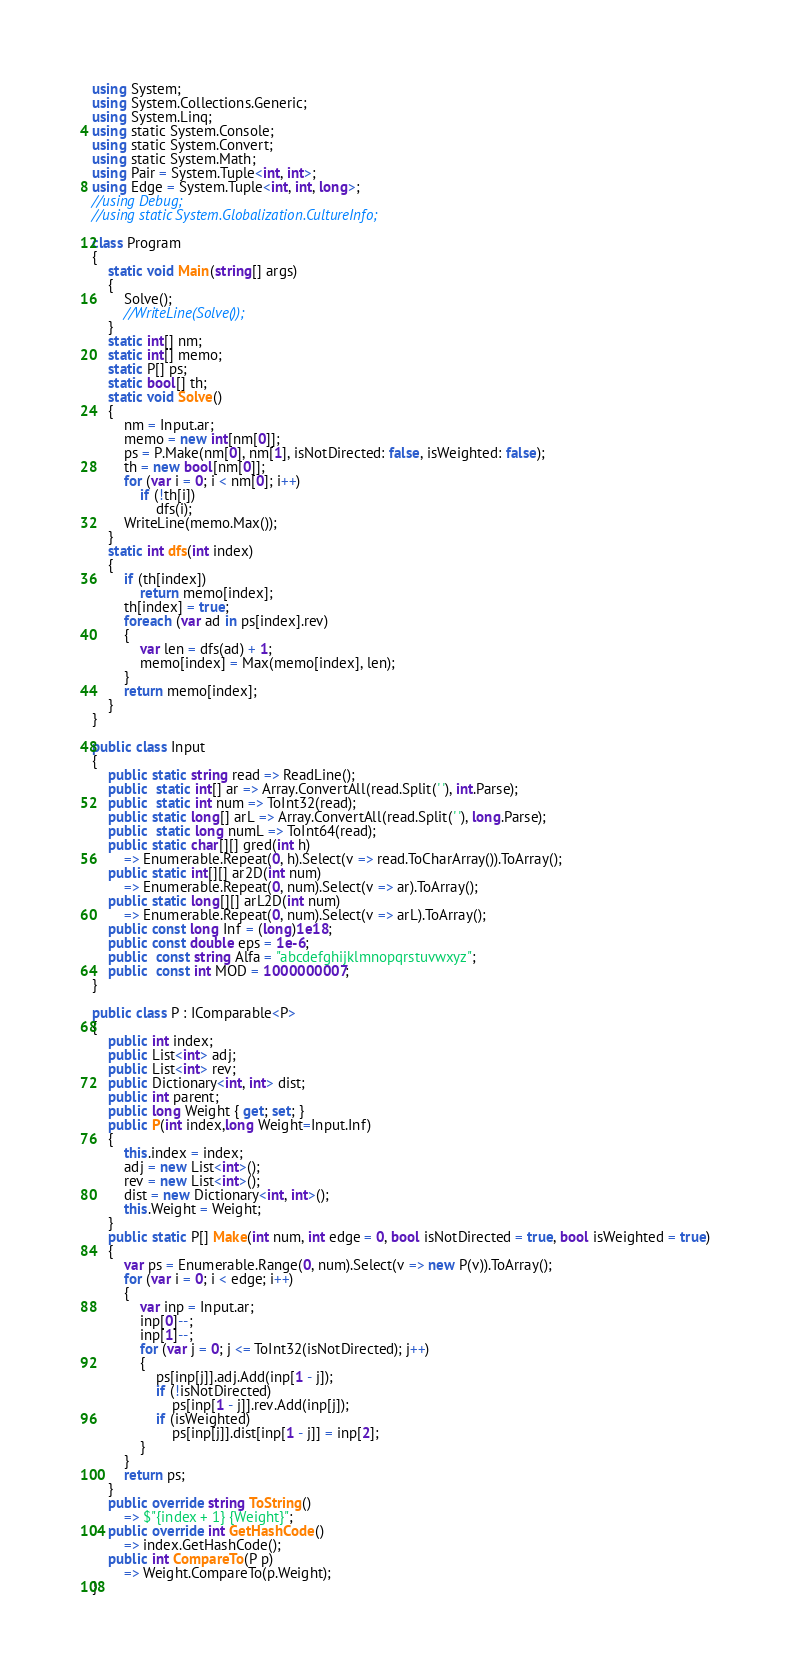<code> <loc_0><loc_0><loc_500><loc_500><_C#_>using System;
using System.Collections.Generic;
using System.Linq;
using static System.Console;
using static System.Convert;
using static System.Math;
using Pair = System.Tuple<int, int>;
using Edge = System.Tuple<int, int, long>;
//using Debug;
//using static System.Globalization.CultureInfo;

class Program
{
    static void Main(string[] args)
    {
        Solve();
        //WriteLine(Solve());
    }
    static int[] nm;
    static int[] memo;
    static P[] ps;
    static bool[] th;
    static void Solve()
    {
        nm = Input.ar;
        memo = new int[nm[0]];
        ps = P.Make(nm[0], nm[1], isNotDirected: false, isWeighted: false);
        th = new bool[nm[0]];
        for (var i = 0; i < nm[0]; i++)
            if (!th[i])
                dfs(i);
        WriteLine(memo.Max());
    }
    static int dfs(int index)
    {
        if (th[index])
            return memo[index];
        th[index] = true;
        foreach (var ad in ps[index].rev)
        {
            var len = dfs(ad) + 1;
            memo[index] = Max(memo[index], len);
        }
        return memo[index];
    }
}

public class Input
{
    public static string read => ReadLine();
    public  static int[] ar => Array.ConvertAll(read.Split(' '), int.Parse);
    public  static int num => ToInt32(read);
    public static long[] arL => Array.ConvertAll(read.Split(' '), long.Parse);
    public  static long numL => ToInt64(read);
    public static char[][] gred(int h) 
        => Enumerable.Repeat(0, h).Select(v => read.ToCharArray()).ToArray();
    public static int[][] ar2D(int num)
        => Enumerable.Repeat(0, num).Select(v => ar).ToArray();
    public static long[][] arL2D(int num)
        => Enumerable.Repeat(0, num).Select(v => arL).ToArray();
    public const long Inf = (long)1e18;
    public const double eps = 1e-6;
    public  const string Alfa = "abcdefghijklmnopqrstuvwxyz";
    public  const int MOD = 1000000007;
}

public class P : IComparable<P>
{
    public int index;
    public List<int> adj;
    public List<int> rev;
    public Dictionary<int, int> dist;
    public int parent;
    public long Weight { get; set; }
    public P(int index,long Weight=Input.Inf)
    {
        this.index = index;
        adj = new List<int>();
        rev = new List<int>();
        dist = new Dictionary<int, int>();
        this.Weight = Weight;
    }
    public static P[] Make(int num, int edge = 0, bool isNotDirected = true, bool isWeighted = true)
    {
        var ps = Enumerable.Range(0, num).Select(v => new P(v)).ToArray();
        for (var i = 0; i < edge; i++)
        {
            var inp = Input.ar;
            inp[0]--;
            inp[1]--;
            for (var j = 0; j <= ToInt32(isNotDirected); j++)
            {
                ps[inp[j]].adj.Add(inp[1 - j]);
                if (!isNotDirected)
                    ps[inp[1 - j]].rev.Add(inp[j]);
                if (isWeighted)
                    ps[inp[j]].dist[inp[1 - j]] = inp[2];
            }
        }
        return ps;
    }
    public override string ToString()
        => $"{index + 1} {Weight}";
    public override int GetHashCode()
        => index.GetHashCode();
    public int CompareTo(P p)
        => Weight.CompareTo(p.Weight);
}
</code> 